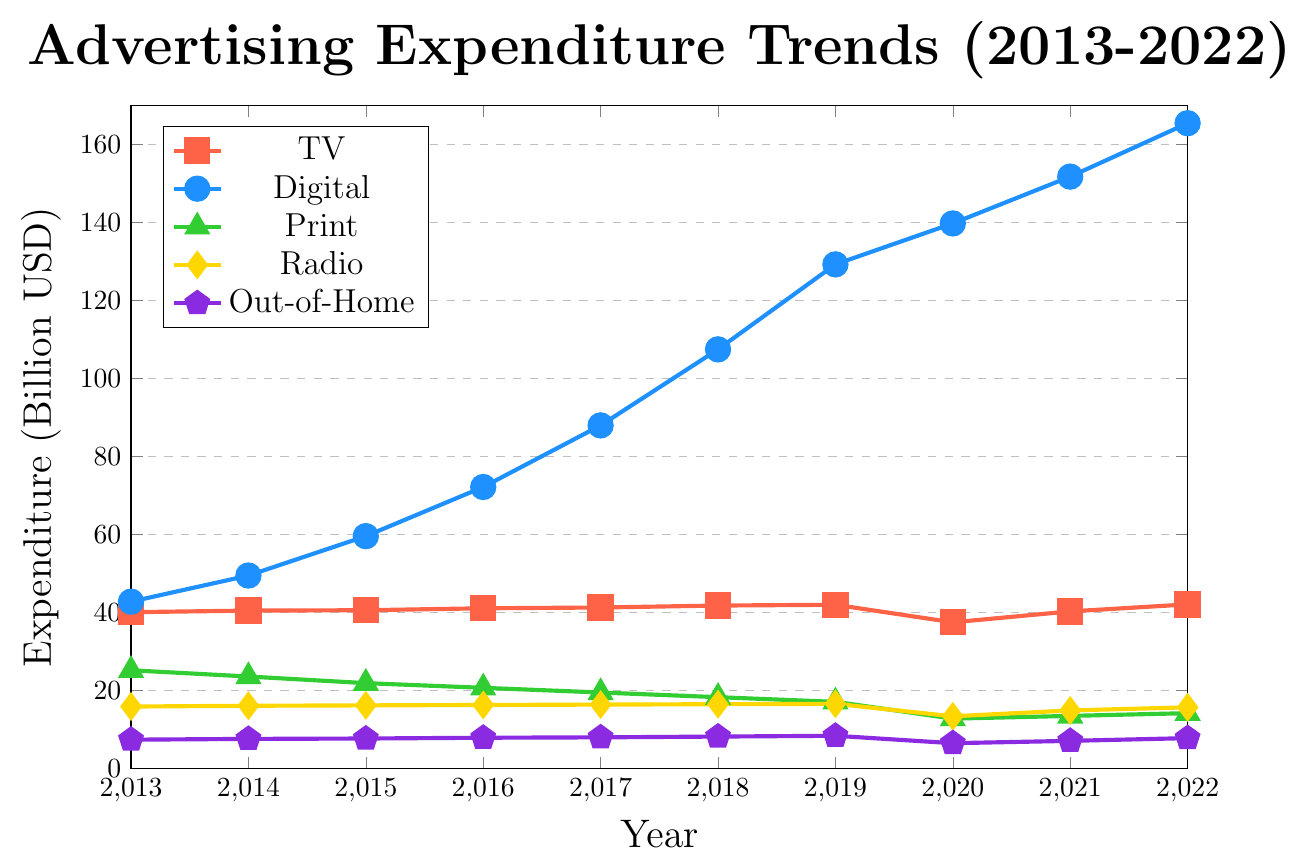What is the total advertising expenditure for Digital media in the years 2015 and 2020? To find the total advertising expenditure for Digital media in 2015 and 2020, sum the values for these years: 59.6 (2015) + 139.8 (2020) = 199.4 billion USD.
Answer: 199.4 billion USD Which media channel had the highest expenditure in 2022? Locate the highest point in 2022 among all media channels. Digital media tops with 165.5 billion USD.
Answer: Digital How did TV advertising expenditure change between 2013 and 2022? Subtract the expenditure in 2013 from the expenditure in 2022 for TV: 42.1 (2022) - 40.1 (2013) = 2 billion USD increase.
Answer: Increased by 2 billion USD What was the expenditure difference between Print and Radio advertising in 2020? Identify the expenditure for both Print and Radio in 2020 and subtract the smaller value from the larger value: 13.4 (Radio) - 12.8 (Print) = 0.6 billion USD.
Answer: 0.6 billion USD Which media channel showed the most consistent expenditure growth from 2013 to 2022? By observing the trends, Digital media showed the most consistent growth with a steady increase each year.
Answer: Digital What is the average advertising expenditure on Out-of-Home media from 2013 to 2022? Sum the Out-of-Home expenditures from 2013 to 2022 and divide by the number of years: (7.4+7.6+7.7+7.9+8.0+8.2+8.4+6.5+7.1+7.8)/10 = 7.66 billion USD.
Answer: 7.66 billion USD Which media channel experienced a drop in expenditure during 2020, and by how much? Compare 2019 and 2020 values for each channel. TV dropped from 42.0 (2019) to 37.5 (2020), a decline of 4.5 billion USD.
Answer: TV, by 4.5 billion USD What is the combined advertising expenditure for Print and Radio media in 2018? Add the expenditures for Print and Radio in 2018: 18.3 (Print) + 16.5 (Radio) = 34.8 billion USD.
Answer: 34.8 billion USD Did any media channel have an expenditure greater than 100 billion USD before 2017? Check the data before 2017 for any media channel exceeding 100 billion USD. No media channel had such an expenditure before 2017.
Answer: No How did Digital advertising expenditure change relative to Out-of-Home from 2013 to 2022? Calculate the difference between Digital and Out-of-Home for both years and compare: 
2013: 42.8 (Digital) - 7.4 (Out-of-Home) = 35.4 billion USD difference
2022: 165.5 (Digital) - 7.8 (Out-of-Home) = 157.7 billion USD difference
The change in difference: 157.7 - 35.4 = 122.3 billion USD
Answer: Increased by 122.3 billion USD 